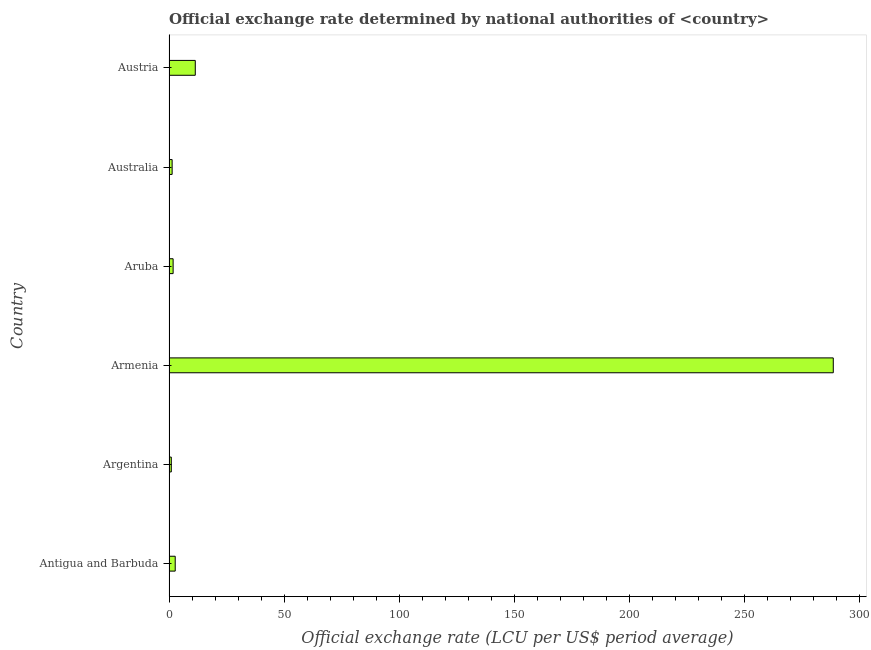Does the graph contain grids?
Your answer should be compact. No. What is the title of the graph?
Your response must be concise. Official exchange rate determined by national authorities of <country>. What is the label or title of the X-axis?
Offer a terse response. Official exchange rate (LCU per US$ period average). What is the label or title of the Y-axis?
Make the answer very short. Country. What is the official exchange rate in Austria?
Make the answer very short. 11.42. Across all countries, what is the maximum official exchange rate?
Make the answer very short. 288.65. Across all countries, what is the minimum official exchange rate?
Your answer should be compact. 1. In which country was the official exchange rate maximum?
Your answer should be very brief. Armenia. In which country was the official exchange rate minimum?
Your answer should be very brief. Argentina. What is the sum of the official exchange rate?
Your response must be concise. 306.93. What is the difference between the official exchange rate in Antigua and Barbuda and Aruba?
Ensure brevity in your answer.  0.91. What is the average official exchange rate per country?
Make the answer very short. 51.16. What is the median official exchange rate?
Give a very brief answer. 2.25. In how many countries, is the official exchange rate greater than 240 ?
Keep it short and to the point. 1. What is the ratio of the official exchange rate in Armenia to that in Australia?
Provide a succinct answer. 211.04. What is the difference between the highest and the second highest official exchange rate?
Give a very brief answer. 277.23. What is the difference between the highest and the lowest official exchange rate?
Make the answer very short. 287.65. In how many countries, is the official exchange rate greater than the average official exchange rate taken over all countries?
Make the answer very short. 1. How many countries are there in the graph?
Offer a very short reply. 6. What is the difference between two consecutive major ticks on the X-axis?
Make the answer very short. 50. Are the values on the major ticks of X-axis written in scientific E-notation?
Your answer should be compact. No. What is the Official exchange rate (LCU per US$ period average) of Argentina?
Ensure brevity in your answer.  1. What is the Official exchange rate (LCU per US$ period average) of Armenia?
Your response must be concise. 288.65. What is the Official exchange rate (LCU per US$ period average) in Aruba?
Provide a short and direct response. 1.79. What is the Official exchange rate (LCU per US$ period average) of Australia?
Make the answer very short. 1.37. What is the Official exchange rate (LCU per US$ period average) in Austria?
Keep it short and to the point. 11.42. What is the difference between the Official exchange rate (LCU per US$ period average) in Antigua and Barbuda and Argentina?
Ensure brevity in your answer.  1.7. What is the difference between the Official exchange rate (LCU per US$ period average) in Antigua and Barbuda and Armenia?
Offer a very short reply. -285.95. What is the difference between the Official exchange rate (LCU per US$ period average) in Antigua and Barbuda and Aruba?
Make the answer very short. 0.91. What is the difference between the Official exchange rate (LCU per US$ period average) in Antigua and Barbuda and Australia?
Your answer should be compact. 1.33. What is the difference between the Official exchange rate (LCU per US$ period average) in Antigua and Barbuda and Austria?
Make the answer very short. -8.72. What is the difference between the Official exchange rate (LCU per US$ period average) in Argentina and Armenia?
Offer a terse response. -287.65. What is the difference between the Official exchange rate (LCU per US$ period average) in Argentina and Aruba?
Your response must be concise. -0.79. What is the difference between the Official exchange rate (LCU per US$ period average) in Argentina and Australia?
Make the answer very short. -0.37. What is the difference between the Official exchange rate (LCU per US$ period average) in Argentina and Austria?
Make the answer very short. -10.42. What is the difference between the Official exchange rate (LCU per US$ period average) in Armenia and Aruba?
Your answer should be very brief. 286.86. What is the difference between the Official exchange rate (LCU per US$ period average) in Armenia and Australia?
Provide a short and direct response. 287.28. What is the difference between the Official exchange rate (LCU per US$ period average) in Armenia and Austria?
Provide a succinct answer. 277.23. What is the difference between the Official exchange rate (LCU per US$ period average) in Aruba and Australia?
Offer a terse response. 0.42. What is the difference between the Official exchange rate (LCU per US$ period average) in Aruba and Austria?
Your answer should be compact. -9.63. What is the difference between the Official exchange rate (LCU per US$ period average) in Australia and Austria?
Your answer should be very brief. -10.05. What is the ratio of the Official exchange rate (LCU per US$ period average) in Antigua and Barbuda to that in Argentina?
Keep it short and to the point. 2.7. What is the ratio of the Official exchange rate (LCU per US$ period average) in Antigua and Barbuda to that in Armenia?
Ensure brevity in your answer.  0.01. What is the ratio of the Official exchange rate (LCU per US$ period average) in Antigua and Barbuda to that in Aruba?
Your answer should be very brief. 1.51. What is the ratio of the Official exchange rate (LCU per US$ period average) in Antigua and Barbuda to that in Australia?
Offer a terse response. 1.97. What is the ratio of the Official exchange rate (LCU per US$ period average) in Antigua and Barbuda to that in Austria?
Give a very brief answer. 0.24. What is the ratio of the Official exchange rate (LCU per US$ period average) in Argentina to that in Armenia?
Offer a terse response. 0. What is the ratio of the Official exchange rate (LCU per US$ period average) in Argentina to that in Aruba?
Offer a terse response. 0.56. What is the ratio of the Official exchange rate (LCU per US$ period average) in Argentina to that in Australia?
Your response must be concise. 0.73. What is the ratio of the Official exchange rate (LCU per US$ period average) in Argentina to that in Austria?
Provide a succinct answer. 0.09. What is the ratio of the Official exchange rate (LCU per US$ period average) in Armenia to that in Aruba?
Provide a succinct answer. 161.26. What is the ratio of the Official exchange rate (LCU per US$ period average) in Armenia to that in Australia?
Provide a succinct answer. 211.04. What is the ratio of the Official exchange rate (LCU per US$ period average) in Armenia to that in Austria?
Ensure brevity in your answer.  25.27. What is the ratio of the Official exchange rate (LCU per US$ period average) in Aruba to that in Australia?
Your response must be concise. 1.31. What is the ratio of the Official exchange rate (LCU per US$ period average) in Aruba to that in Austria?
Give a very brief answer. 0.16. What is the ratio of the Official exchange rate (LCU per US$ period average) in Australia to that in Austria?
Your answer should be very brief. 0.12. 